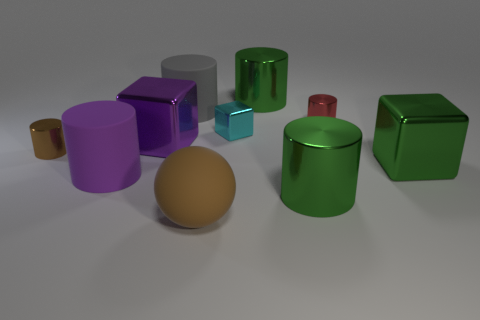What materials do the objects in the image seem to be made from? The objects in the image appear to be 3D renderings made to resemble various materials. We have gleaming metallic-like surfaces on the cylinders and cubes, a glassy texture on the gray cube, and what resembles a soft, matte surface on the brown sphere. 